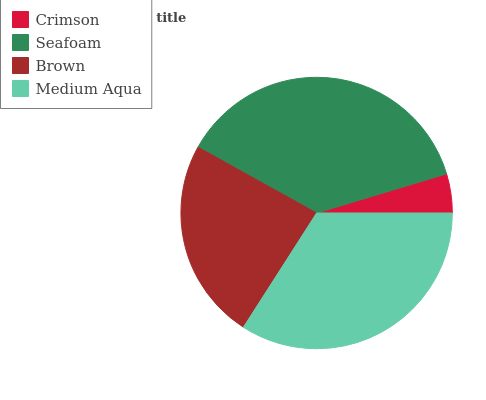Is Crimson the minimum?
Answer yes or no. Yes. Is Seafoam the maximum?
Answer yes or no. Yes. Is Brown the minimum?
Answer yes or no. No. Is Brown the maximum?
Answer yes or no. No. Is Seafoam greater than Brown?
Answer yes or no. Yes. Is Brown less than Seafoam?
Answer yes or no. Yes. Is Brown greater than Seafoam?
Answer yes or no. No. Is Seafoam less than Brown?
Answer yes or no. No. Is Medium Aqua the high median?
Answer yes or no. Yes. Is Brown the low median?
Answer yes or no. Yes. Is Crimson the high median?
Answer yes or no. No. Is Seafoam the low median?
Answer yes or no. No. 